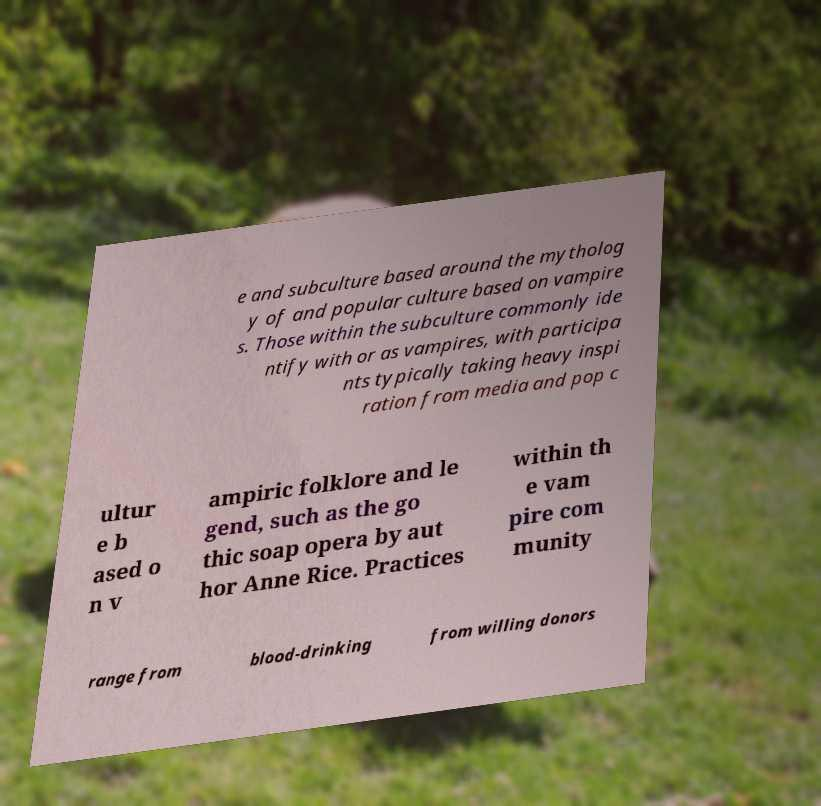Can you accurately transcribe the text from the provided image for me? e and subculture based around the mytholog y of and popular culture based on vampire s. Those within the subculture commonly ide ntify with or as vampires, with participa nts typically taking heavy inspi ration from media and pop c ultur e b ased o n v ampiric folklore and le gend, such as the go thic soap opera by aut hor Anne Rice. Practices within th e vam pire com munity range from blood-drinking from willing donors 